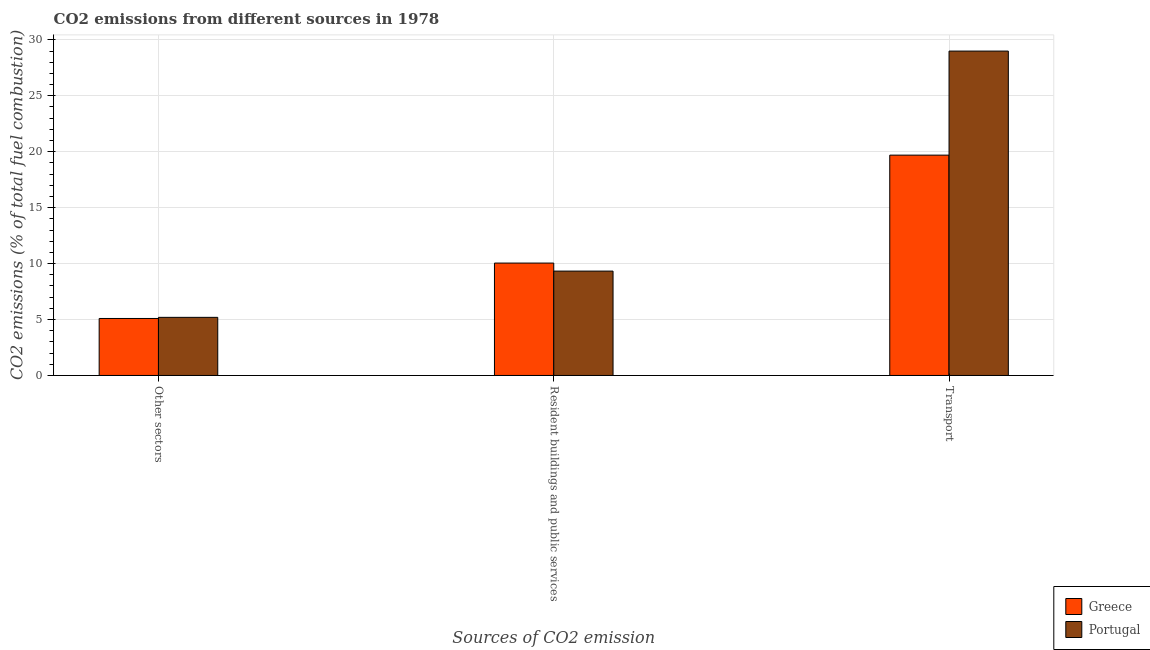How many groups of bars are there?
Your response must be concise. 3. Are the number of bars per tick equal to the number of legend labels?
Offer a very short reply. Yes. How many bars are there on the 1st tick from the left?
Ensure brevity in your answer.  2. What is the label of the 1st group of bars from the left?
Keep it short and to the point. Other sectors. What is the percentage of co2 emissions from resident buildings and public services in Portugal?
Provide a short and direct response. 9.33. Across all countries, what is the maximum percentage of co2 emissions from transport?
Offer a very short reply. 29. Across all countries, what is the minimum percentage of co2 emissions from other sectors?
Provide a succinct answer. 5.09. In which country was the percentage of co2 emissions from resident buildings and public services maximum?
Ensure brevity in your answer.  Greece. What is the total percentage of co2 emissions from resident buildings and public services in the graph?
Ensure brevity in your answer.  19.38. What is the difference between the percentage of co2 emissions from transport in Greece and that in Portugal?
Give a very brief answer. -9.3. What is the difference between the percentage of co2 emissions from resident buildings and public services in Greece and the percentage of co2 emissions from transport in Portugal?
Give a very brief answer. -18.95. What is the average percentage of co2 emissions from resident buildings and public services per country?
Your response must be concise. 9.69. What is the difference between the percentage of co2 emissions from resident buildings and public services and percentage of co2 emissions from other sectors in Portugal?
Offer a very short reply. 4.14. In how many countries, is the percentage of co2 emissions from resident buildings and public services greater than 19 %?
Make the answer very short. 0. What is the ratio of the percentage of co2 emissions from resident buildings and public services in Greece to that in Portugal?
Provide a succinct answer. 1.08. Is the percentage of co2 emissions from resident buildings and public services in Portugal less than that in Greece?
Your response must be concise. Yes. Is the difference between the percentage of co2 emissions from resident buildings and public services in Greece and Portugal greater than the difference between the percentage of co2 emissions from other sectors in Greece and Portugal?
Offer a very short reply. Yes. What is the difference between the highest and the second highest percentage of co2 emissions from other sectors?
Provide a succinct answer. 0.1. What is the difference between the highest and the lowest percentage of co2 emissions from other sectors?
Offer a very short reply. 0.1. In how many countries, is the percentage of co2 emissions from other sectors greater than the average percentage of co2 emissions from other sectors taken over all countries?
Your answer should be compact. 1. Is the sum of the percentage of co2 emissions from other sectors in Greece and Portugal greater than the maximum percentage of co2 emissions from transport across all countries?
Your response must be concise. No. How many countries are there in the graph?
Offer a terse response. 2. What is the difference between two consecutive major ticks on the Y-axis?
Provide a short and direct response. 5. Are the values on the major ticks of Y-axis written in scientific E-notation?
Ensure brevity in your answer.  No. Does the graph contain grids?
Offer a terse response. Yes. How many legend labels are there?
Offer a very short reply. 2. What is the title of the graph?
Keep it short and to the point. CO2 emissions from different sources in 1978. Does "Nigeria" appear as one of the legend labels in the graph?
Your answer should be very brief. No. What is the label or title of the X-axis?
Ensure brevity in your answer.  Sources of CO2 emission. What is the label or title of the Y-axis?
Your response must be concise. CO2 emissions (% of total fuel combustion). What is the CO2 emissions (% of total fuel combustion) of Greece in Other sectors?
Give a very brief answer. 5.09. What is the CO2 emissions (% of total fuel combustion) of Portugal in Other sectors?
Give a very brief answer. 5.19. What is the CO2 emissions (% of total fuel combustion) in Greece in Resident buildings and public services?
Keep it short and to the point. 10.05. What is the CO2 emissions (% of total fuel combustion) of Portugal in Resident buildings and public services?
Provide a succinct answer. 9.33. What is the CO2 emissions (% of total fuel combustion) in Greece in Transport?
Your answer should be compact. 19.7. What is the CO2 emissions (% of total fuel combustion) in Portugal in Transport?
Keep it short and to the point. 29. Across all Sources of CO2 emission, what is the maximum CO2 emissions (% of total fuel combustion) of Greece?
Provide a short and direct response. 19.7. Across all Sources of CO2 emission, what is the maximum CO2 emissions (% of total fuel combustion) of Portugal?
Ensure brevity in your answer.  29. Across all Sources of CO2 emission, what is the minimum CO2 emissions (% of total fuel combustion) in Greece?
Keep it short and to the point. 5.09. Across all Sources of CO2 emission, what is the minimum CO2 emissions (% of total fuel combustion) in Portugal?
Give a very brief answer. 5.19. What is the total CO2 emissions (% of total fuel combustion) of Greece in the graph?
Your answer should be very brief. 34.84. What is the total CO2 emissions (% of total fuel combustion) of Portugal in the graph?
Provide a succinct answer. 43.52. What is the difference between the CO2 emissions (% of total fuel combustion) in Greece in Other sectors and that in Resident buildings and public services?
Your answer should be compact. -4.95. What is the difference between the CO2 emissions (% of total fuel combustion) of Portugal in Other sectors and that in Resident buildings and public services?
Provide a succinct answer. -4.14. What is the difference between the CO2 emissions (% of total fuel combustion) in Greece in Other sectors and that in Transport?
Make the answer very short. -14.6. What is the difference between the CO2 emissions (% of total fuel combustion) in Portugal in Other sectors and that in Transport?
Ensure brevity in your answer.  -23.8. What is the difference between the CO2 emissions (% of total fuel combustion) of Greece in Resident buildings and public services and that in Transport?
Offer a terse response. -9.65. What is the difference between the CO2 emissions (% of total fuel combustion) of Portugal in Resident buildings and public services and that in Transport?
Ensure brevity in your answer.  -19.67. What is the difference between the CO2 emissions (% of total fuel combustion) in Greece in Other sectors and the CO2 emissions (% of total fuel combustion) in Portugal in Resident buildings and public services?
Your answer should be compact. -4.24. What is the difference between the CO2 emissions (% of total fuel combustion) of Greece in Other sectors and the CO2 emissions (% of total fuel combustion) of Portugal in Transport?
Offer a terse response. -23.9. What is the difference between the CO2 emissions (% of total fuel combustion) of Greece in Resident buildings and public services and the CO2 emissions (% of total fuel combustion) of Portugal in Transport?
Your answer should be compact. -18.95. What is the average CO2 emissions (% of total fuel combustion) of Greece per Sources of CO2 emission?
Ensure brevity in your answer.  11.61. What is the average CO2 emissions (% of total fuel combustion) in Portugal per Sources of CO2 emission?
Your response must be concise. 14.51. What is the difference between the CO2 emissions (% of total fuel combustion) in Greece and CO2 emissions (% of total fuel combustion) in Portugal in Other sectors?
Your answer should be compact. -0.1. What is the difference between the CO2 emissions (% of total fuel combustion) in Greece and CO2 emissions (% of total fuel combustion) in Portugal in Resident buildings and public services?
Ensure brevity in your answer.  0.72. What is the difference between the CO2 emissions (% of total fuel combustion) of Greece and CO2 emissions (% of total fuel combustion) of Portugal in Transport?
Your response must be concise. -9.3. What is the ratio of the CO2 emissions (% of total fuel combustion) in Greece in Other sectors to that in Resident buildings and public services?
Provide a succinct answer. 0.51. What is the ratio of the CO2 emissions (% of total fuel combustion) in Portugal in Other sectors to that in Resident buildings and public services?
Your response must be concise. 0.56. What is the ratio of the CO2 emissions (% of total fuel combustion) of Greece in Other sectors to that in Transport?
Offer a terse response. 0.26. What is the ratio of the CO2 emissions (% of total fuel combustion) of Portugal in Other sectors to that in Transport?
Offer a terse response. 0.18. What is the ratio of the CO2 emissions (% of total fuel combustion) of Greece in Resident buildings and public services to that in Transport?
Offer a terse response. 0.51. What is the ratio of the CO2 emissions (% of total fuel combustion) in Portugal in Resident buildings and public services to that in Transport?
Your answer should be very brief. 0.32. What is the difference between the highest and the second highest CO2 emissions (% of total fuel combustion) of Greece?
Give a very brief answer. 9.65. What is the difference between the highest and the second highest CO2 emissions (% of total fuel combustion) in Portugal?
Provide a short and direct response. 19.67. What is the difference between the highest and the lowest CO2 emissions (% of total fuel combustion) in Greece?
Your answer should be compact. 14.6. What is the difference between the highest and the lowest CO2 emissions (% of total fuel combustion) in Portugal?
Your response must be concise. 23.8. 